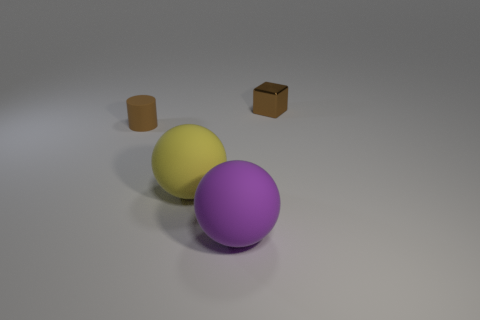Add 1 brown shiny objects. How many objects exist? 5 Subtract all cubes. How many objects are left? 3 Subtract all big purple matte balls. Subtract all large purple matte cubes. How many objects are left? 3 Add 4 small rubber objects. How many small rubber objects are left? 5 Add 4 matte spheres. How many matte spheres exist? 6 Subtract 1 brown cylinders. How many objects are left? 3 